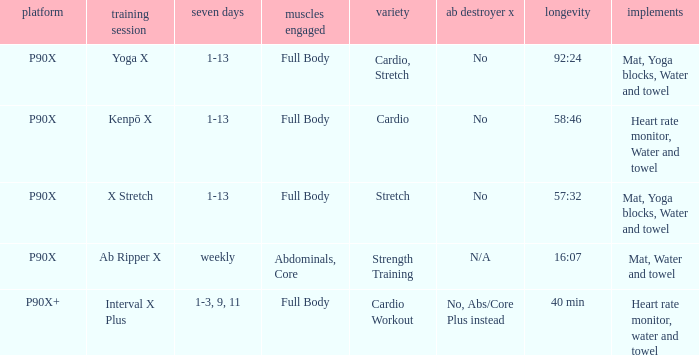What is the exercise when the equipment is heart rate monitor, water and towel? Kenpō X, Interval X Plus. 